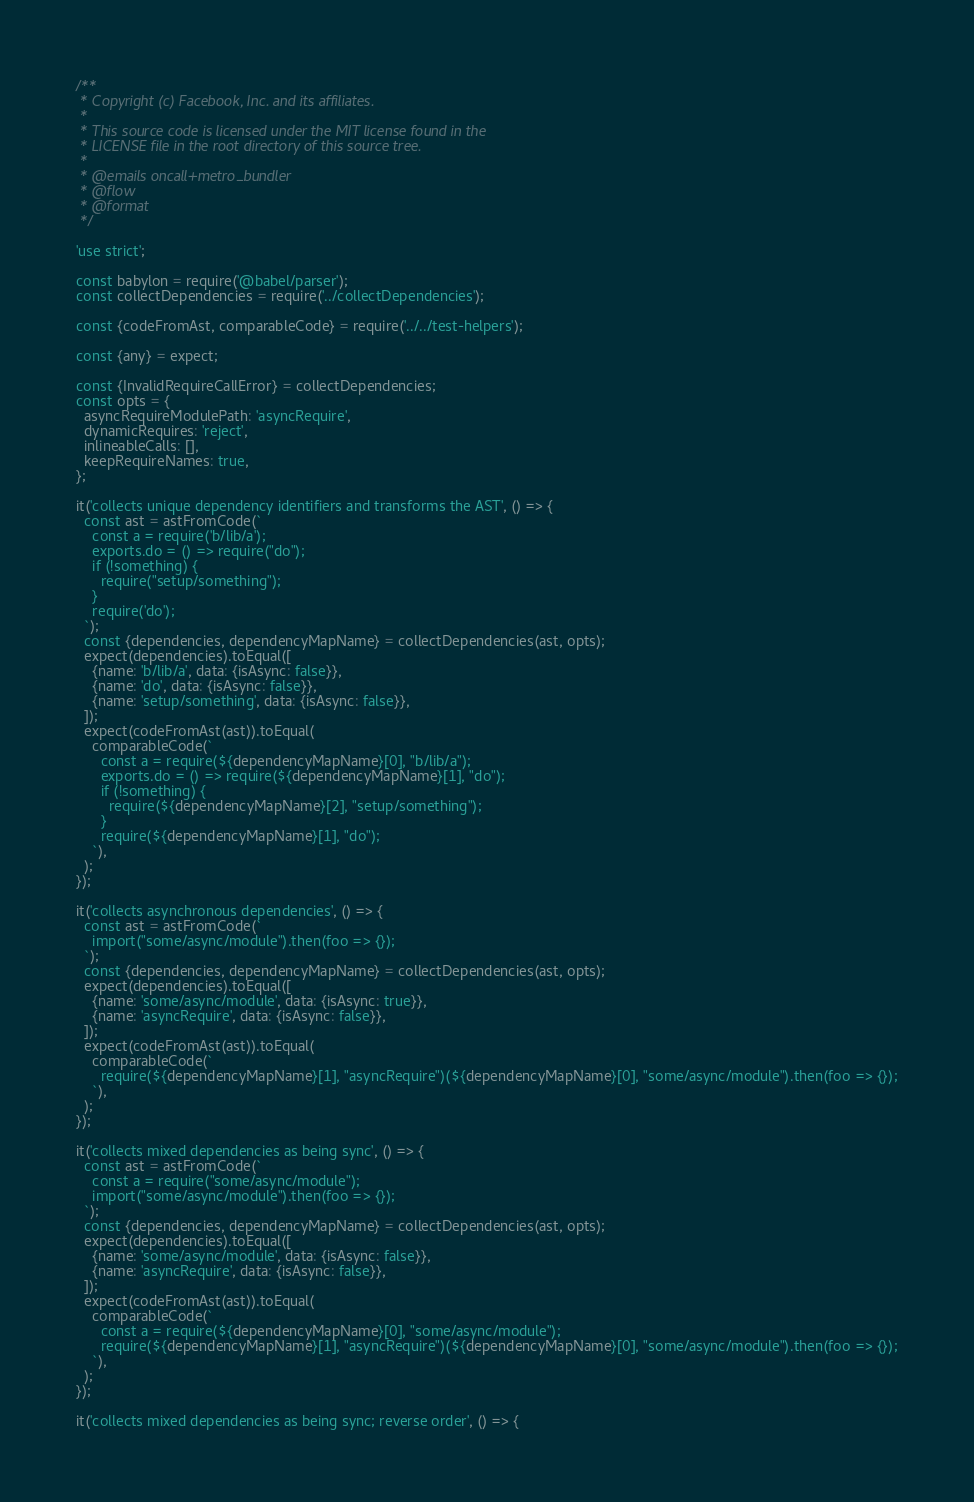<code> <loc_0><loc_0><loc_500><loc_500><_JavaScript_>/**
 * Copyright (c) Facebook, Inc. and its affiliates.
 *
 * This source code is licensed under the MIT license found in the
 * LICENSE file in the root directory of this source tree.
 *
 * @emails oncall+metro_bundler
 * @flow
 * @format
 */

'use strict';

const babylon = require('@babel/parser');
const collectDependencies = require('../collectDependencies');

const {codeFromAst, comparableCode} = require('../../test-helpers');

const {any} = expect;

const {InvalidRequireCallError} = collectDependencies;
const opts = {
  asyncRequireModulePath: 'asyncRequire',
  dynamicRequires: 'reject',
  inlineableCalls: [],
  keepRequireNames: true,
};

it('collects unique dependency identifiers and transforms the AST', () => {
  const ast = astFromCode(`
    const a = require('b/lib/a');
    exports.do = () => require("do");
    if (!something) {
      require("setup/something");
    }
    require('do');
  `);
  const {dependencies, dependencyMapName} = collectDependencies(ast, opts);
  expect(dependencies).toEqual([
    {name: 'b/lib/a', data: {isAsync: false}},
    {name: 'do', data: {isAsync: false}},
    {name: 'setup/something', data: {isAsync: false}},
  ]);
  expect(codeFromAst(ast)).toEqual(
    comparableCode(`
      const a = require(${dependencyMapName}[0], "b/lib/a");
      exports.do = () => require(${dependencyMapName}[1], "do");
      if (!something) {
        require(${dependencyMapName}[2], "setup/something");
      }
      require(${dependencyMapName}[1], "do");
    `),
  );
});

it('collects asynchronous dependencies', () => {
  const ast = astFromCode(`
    import("some/async/module").then(foo => {});
  `);
  const {dependencies, dependencyMapName} = collectDependencies(ast, opts);
  expect(dependencies).toEqual([
    {name: 'some/async/module', data: {isAsync: true}},
    {name: 'asyncRequire', data: {isAsync: false}},
  ]);
  expect(codeFromAst(ast)).toEqual(
    comparableCode(`
      require(${dependencyMapName}[1], "asyncRequire")(${dependencyMapName}[0], "some/async/module").then(foo => {});
    `),
  );
});

it('collects mixed dependencies as being sync', () => {
  const ast = astFromCode(`
    const a = require("some/async/module");
    import("some/async/module").then(foo => {});
  `);
  const {dependencies, dependencyMapName} = collectDependencies(ast, opts);
  expect(dependencies).toEqual([
    {name: 'some/async/module', data: {isAsync: false}},
    {name: 'asyncRequire', data: {isAsync: false}},
  ]);
  expect(codeFromAst(ast)).toEqual(
    comparableCode(`
      const a = require(${dependencyMapName}[0], "some/async/module");
      require(${dependencyMapName}[1], "asyncRequire")(${dependencyMapName}[0], "some/async/module").then(foo => {});
    `),
  );
});

it('collects mixed dependencies as being sync; reverse order', () => {</code> 